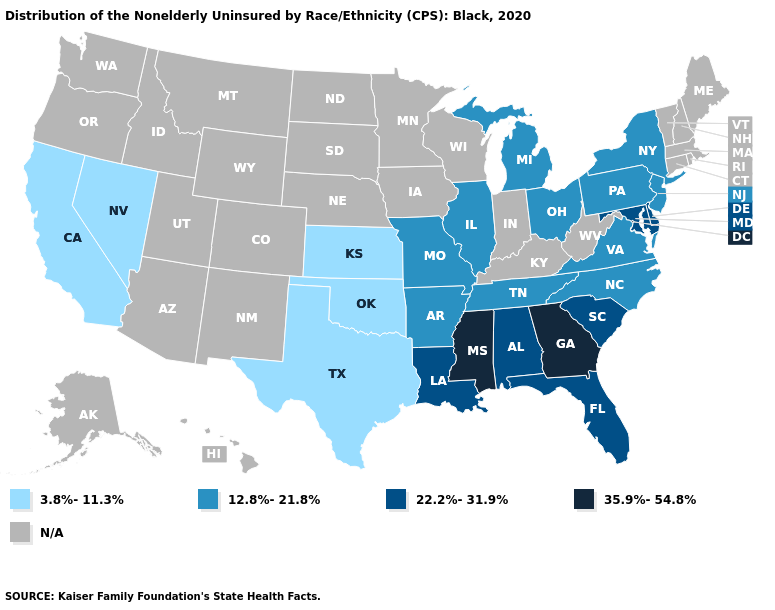Does the map have missing data?
Be succinct. Yes. What is the value of Mississippi?
Be succinct. 35.9%-54.8%. What is the value of Iowa?
Short answer required. N/A. Name the states that have a value in the range N/A?
Short answer required. Alaska, Arizona, Colorado, Connecticut, Hawaii, Idaho, Indiana, Iowa, Kentucky, Maine, Massachusetts, Minnesota, Montana, Nebraska, New Hampshire, New Mexico, North Dakota, Oregon, Rhode Island, South Dakota, Utah, Vermont, Washington, West Virginia, Wisconsin, Wyoming. Among the states that border California , which have the highest value?
Short answer required. Nevada. Name the states that have a value in the range 35.9%-54.8%?
Give a very brief answer. Georgia, Mississippi. Name the states that have a value in the range 35.9%-54.8%?
Quick response, please. Georgia, Mississippi. Name the states that have a value in the range 12.8%-21.8%?
Give a very brief answer. Arkansas, Illinois, Michigan, Missouri, New Jersey, New York, North Carolina, Ohio, Pennsylvania, Tennessee, Virginia. What is the lowest value in the USA?
Concise answer only. 3.8%-11.3%. What is the highest value in the USA?
Give a very brief answer. 35.9%-54.8%. Among the states that border Maryland , does Delaware have the highest value?
Answer briefly. Yes. What is the value of Illinois?
Answer briefly. 12.8%-21.8%. Is the legend a continuous bar?
Write a very short answer. No. Which states have the lowest value in the West?
Keep it brief. California, Nevada. 